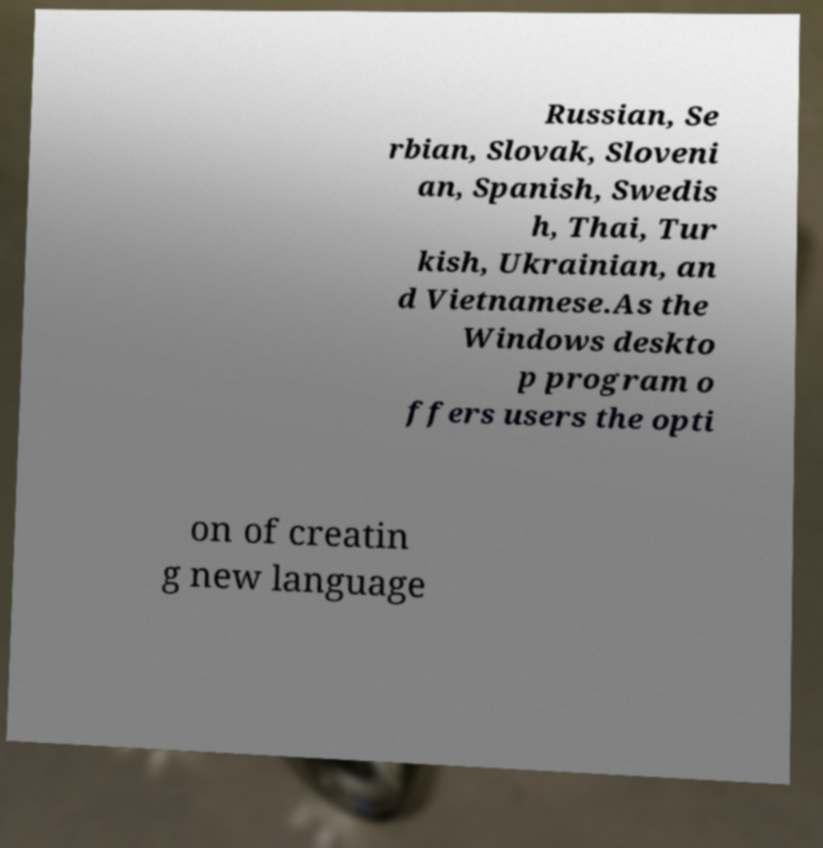I need the written content from this picture converted into text. Can you do that? Russian, Se rbian, Slovak, Sloveni an, Spanish, Swedis h, Thai, Tur kish, Ukrainian, an d Vietnamese.As the Windows deskto p program o ffers users the opti on of creatin g new language 